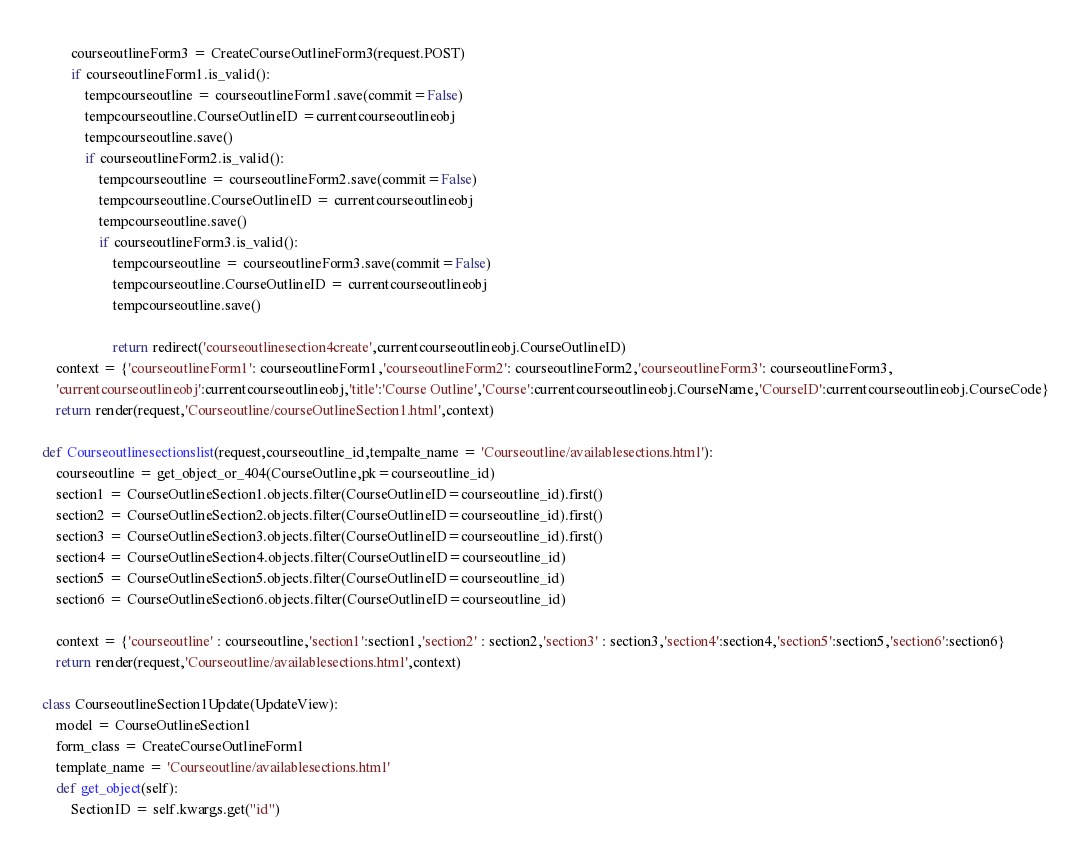<code> <loc_0><loc_0><loc_500><loc_500><_Python_>        courseoutlineForm3 = CreateCourseOutlineForm3(request.POST)
        if courseoutlineForm1.is_valid():
            tempcourseoutline = courseoutlineForm1.save(commit=False)
            tempcourseoutline.CourseOutlineID =currentcourseoutlineobj
            tempcourseoutline.save()
            if courseoutlineForm2.is_valid():
                tempcourseoutline = courseoutlineForm2.save(commit=False)
                tempcourseoutline.CourseOutlineID = currentcourseoutlineobj
                tempcourseoutline.save()
                if courseoutlineForm3.is_valid():
                    tempcourseoutline = courseoutlineForm3.save(commit=False)
                    tempcourseoutline.CourseOutlineID = currentcourseoutlineobj
                    tempcourseoutline.save()
        
                    return redirect('courseoutlinesection4create',currentcourseoutlineobj.CourseOutlineID)
    context = {'courseoutlineForm1': courseoutlineForm1,'courseoutlineForm2': courseoutlineForm2,'courseoutlineForm3': courseoutlineForm3,
    'currentcourseoutlineobj':currentcourseoutlineobj,'title':'Course Outline','Course':currentcourseoutlineobj.CourseName,'CourseID':currentcourseoutlineobj.CourseCode}
    return render(request,'Courseoutline/courseOutlineSection1.html',context)

def Courseoutlinesectionslist(request,courseoutline_id,tempalte_name = 'Courseoutline/availablesections.html'):
    courseoutline = get_object_or_404(CourseOutline,pk=courseoutline_id)
    section1 = CourseOutlineSection1.objects.filter(CourseOutlineID=courseoutline_id).first()
    section2 = CourseOutlineSection2.objects.filter(CourseOutlineID=courseoutline_id).first()
    section3 = CourseOutlineSection3.objects.filter(CourseOutlineID=courseoutline_id).first()
    section4 = CourseOutlineSection4.objects.filter(CourseOutlineID=courseoutline_id)
    section5 = CourseOutlineSection5.objects.filter(CourseOutlineID=courseoutline_id)
    section6 = CourseOutlineSection6.objects.filter(CourseOutlineID=courseoutline_id)

    context = {'courseoutline' : courseoutline,'section1':section1,'section2' : section2,'section3' : section3,'section4':section4,'section5':section5,'section6':section6}
    return render(request,'Courseoutline/availablesections.html',context)

class CourseoutlineSection1Update(UpdateView):
    model = CourseOutlineSection1
    form_class = CreateCourseOutlineForm1
    template_name = 'Courseoutline/availablesections.html'
    def get_object(self):
        SectionID = self.kwargs.get("id")</code> 